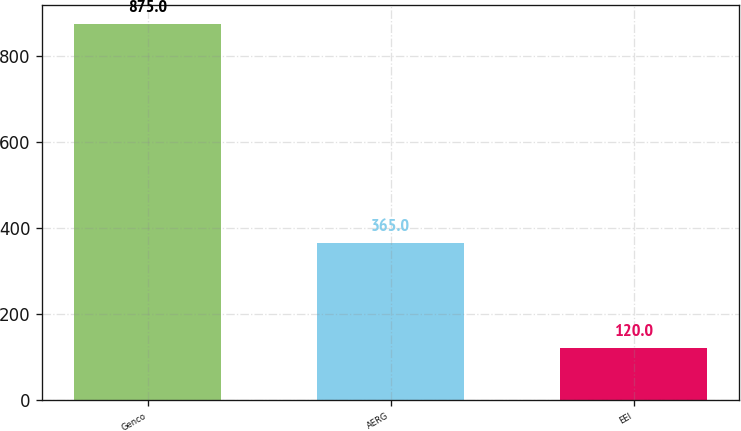Convert chart to OTSL. <chart><loc_0><loc_0><loc_500><loc_500><bar_chart><fcel>Genco<fcel>AERG<fcel>EEI<nl><fcel>875<fcel>365<fcel>120<nl></chart> 